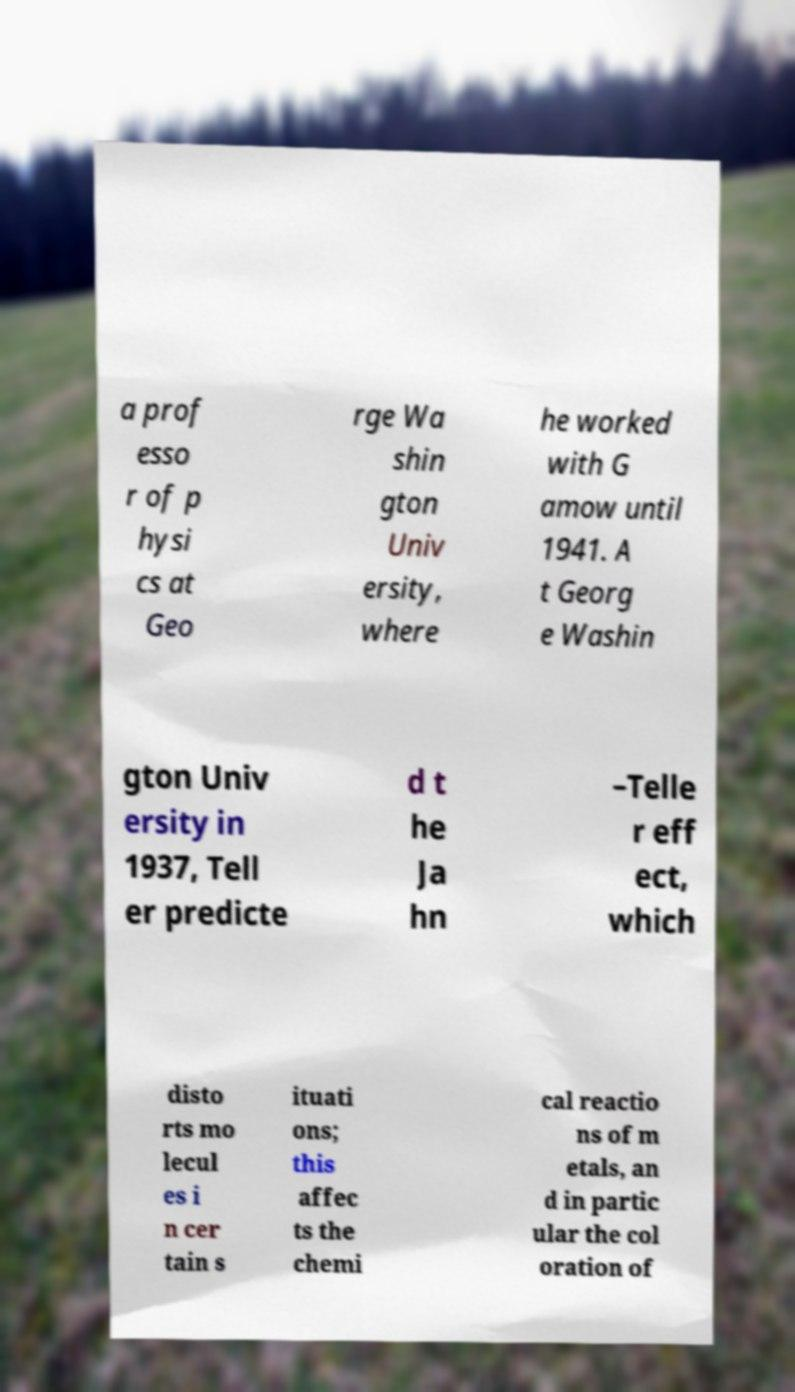Could you extract and type out the text from this image? a prof esso r of p hysi cs at Geo rge Wa shin gton Univ ersity, where he worked with G amow until 1941. A t Georg e Washin gton Univ ersity in 1937, Tell er predicte d t he Ja hn –Telle r eff ect, which disto rts mo lecul es i n cer tain s ituati ons; this affec ts the chemi cal reactio ns of m etals, an d in partic ular the col oration of 